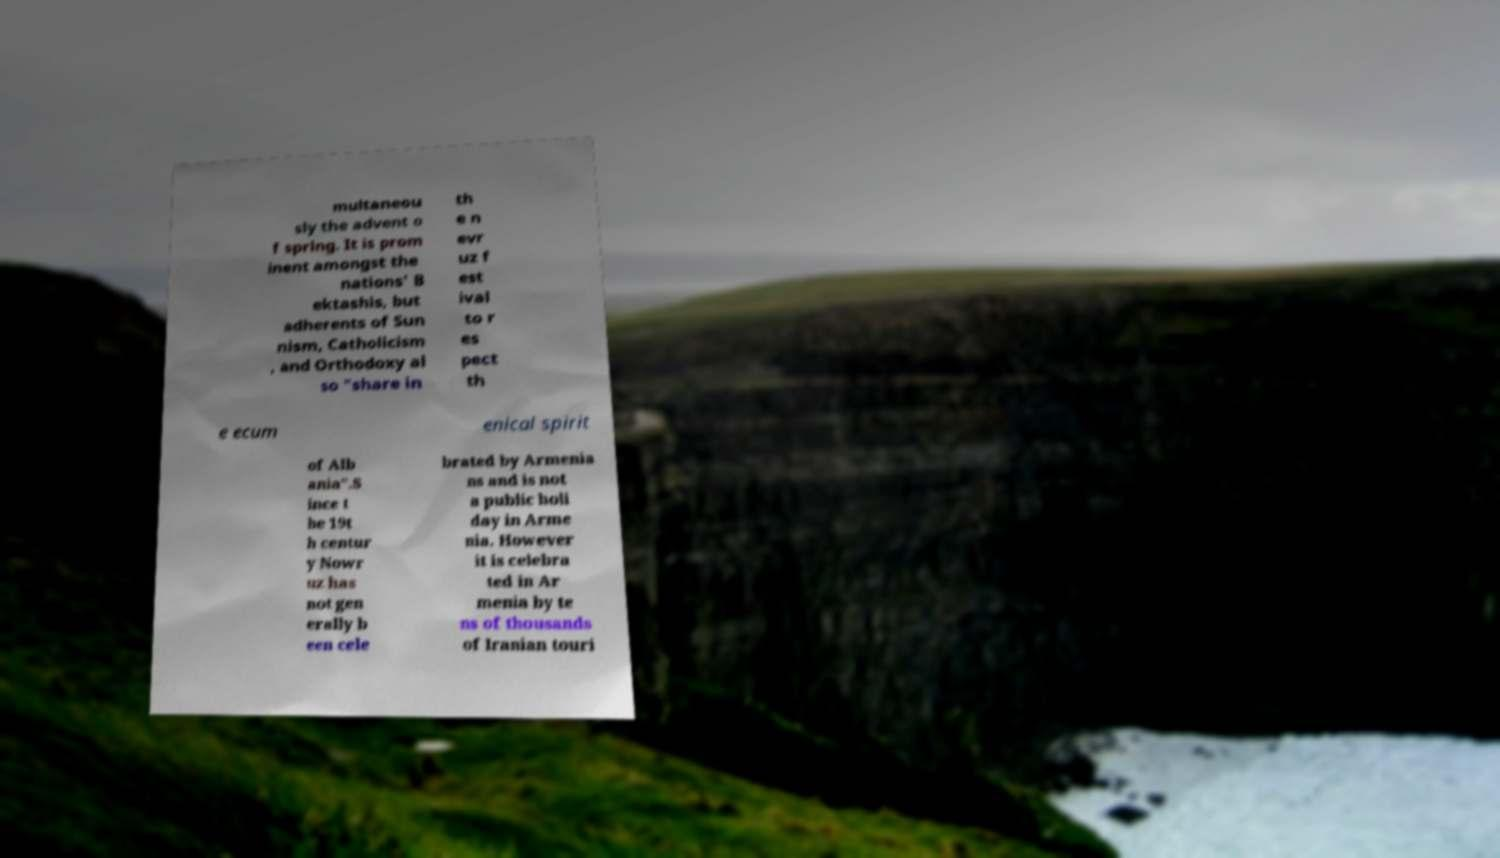Can you read and provide the text displayed in the image?This photo seems to have some interesting text. Can you extract and type it out for me? multaneou sly the advent o f spring. It is prom inent amongst the nations' B ektashis, but adherents of Sun nism, Catholicism , and Orthodoxy al so "share in th e n evr uz f est ival to r es pect th e ecum enical spirit of Alb ania".S ince t he 19t h centur y Nowr uz has not gen erally b een cele brated by Armenia ns and is not a public holi day in Arme nia. However it is celebra ted in Ar menia by te ns of thousands of Iranian touri 